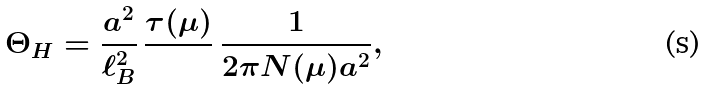Convert formula to latex. <formula><loc_0><loc_0><loc_500><loc_500>\Theta _ { H } = \frac { a ^ { 2 } } { \ell _ { B } ^ { 2 } } \, \frac { \tau ( \mu ) } { } \, \frac { 1 } { 2 \pi N ( \mu ) a ^ { 2 } } ,</formula> 